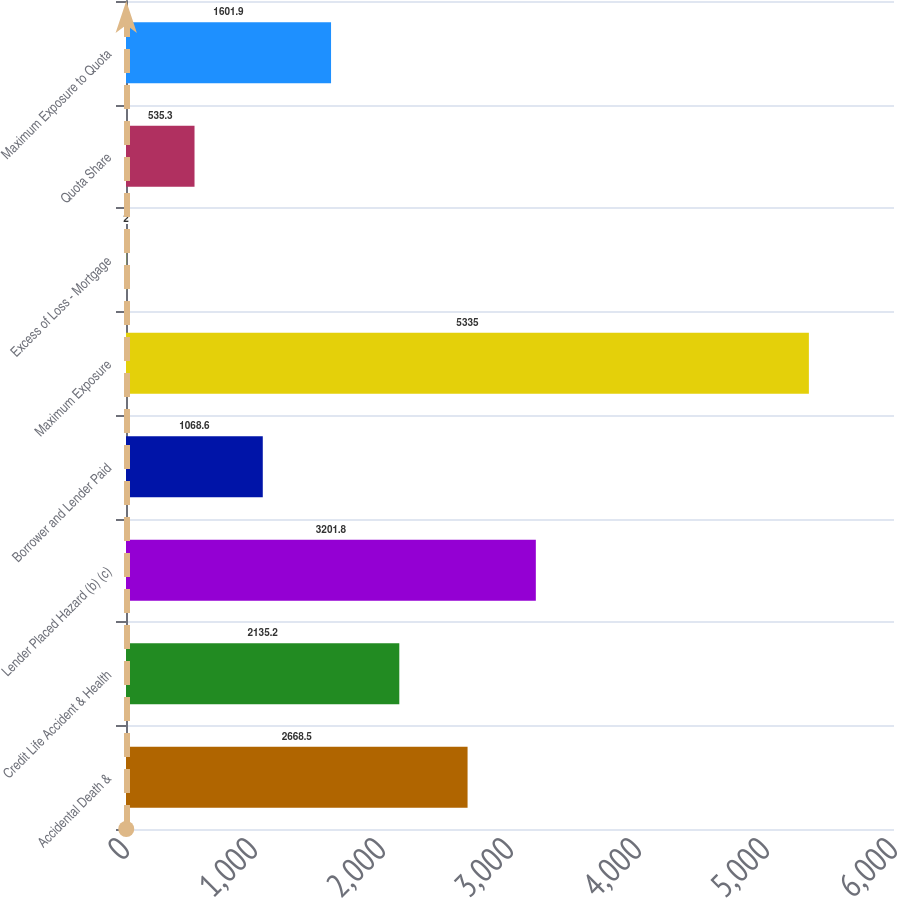<chart> <loc_0><loc_0><loc_500><loc_500><bar_chart><fcel>Accidental Death &<fcel>Credit Life Accident & Health<fcel>Lender Placed Hazard (b) (c)<fcel>Borrower and Lender Paid<fcel>Maximum Exposure<fcel>Excess of Loss - Mortgage<fcel>Quota Share<fcel>Maximum Exposure to Quota<nl><fcel>2668.5<fcel>2135.2<fcel>3201.8<fcel>1068.6<fcel>5335<fcel>2<fcel>535.3<fcel>1601.9<nl></chart> 